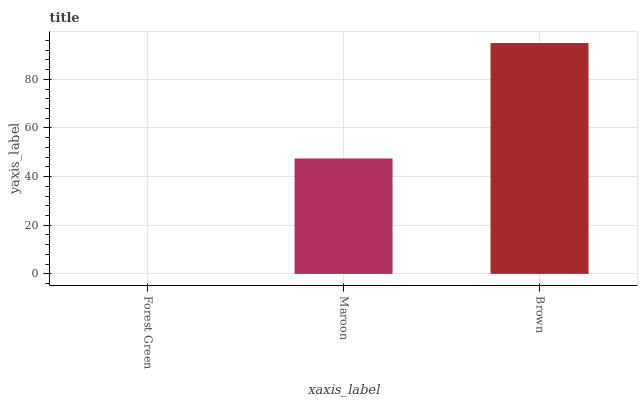Is Forest Green the minimum?
Answer yes or no. Yes. Is Brown the maximum?
Answer yes or no. Yes. Is Maroon the minimum?
Answer yes or no. No. Is Maroon the maximum?
Answer yes or no. No. Is Maroon greater than Forest Green?
Answer yes or no. Yes. Is Forest Green less than Maroon?
Answer yes or no. Yes. Is Forest Green greater than Maroon?
Answer yes or no. No. Is Maroon less than Forest Green?
Answer yes or no. No. Is Maroon the high median?
Answer yes or no. Yes. Is Maroon the low median?
Answer yes or no. Yes. Is Brown the high median?
Answer yes or no. No. Is Brown the low median?
Answer yes or no. No. 